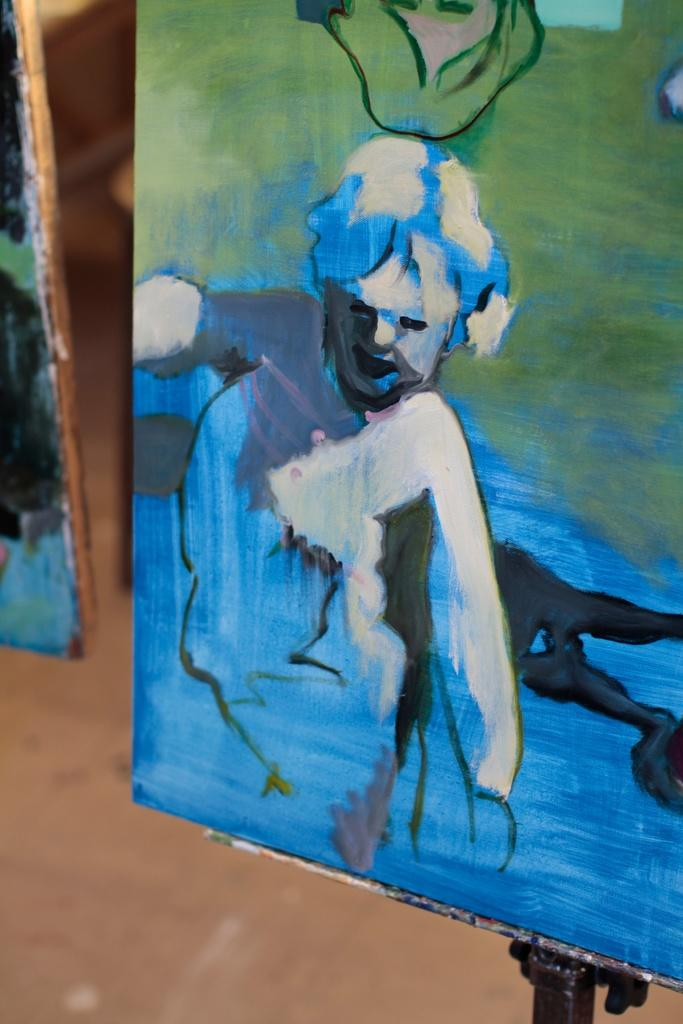What objects can be seen in the image? There are boards in the image. What is depicted on one of the boards? There is a painting of a person on one of the boards. What can be seen beneath the boards in the image? The floor is visible in the image. What type of plough is being used in the hospital depicted in the image? There is no plough or hospital present in the image; it features boards with a painting of a person. How is the connection between the two people in the painting established in the image? There is no connection between two people in the painting, as it only depicts a single person. 